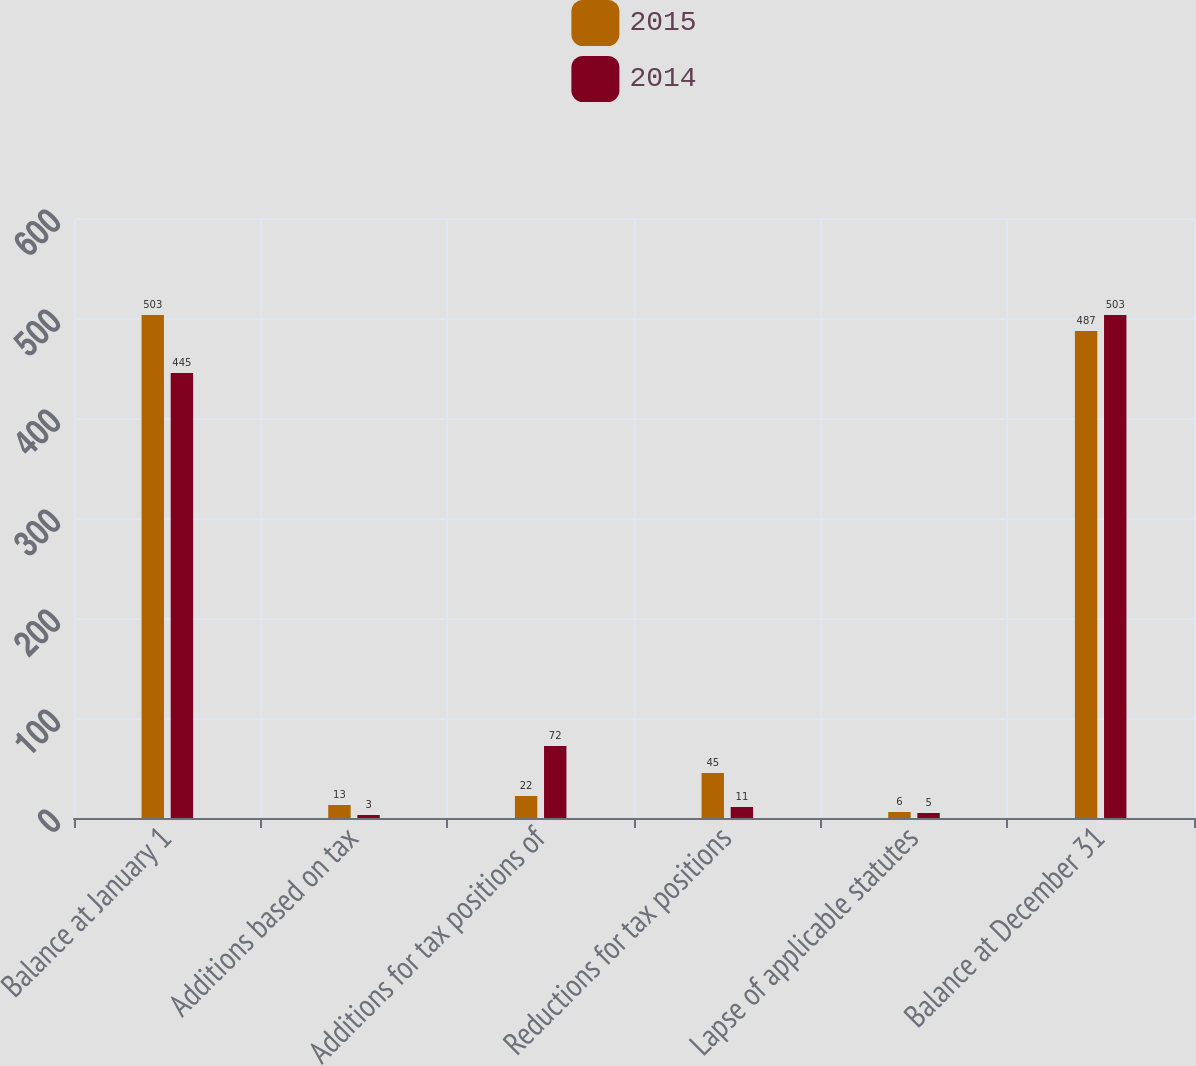<chart> <loc_0><loc_0><loc_500><loc_500><stacked_bar_chart><ecel><fcel>Balance at January 1<fcel>Additions based on tax<fcel>Additions for tax positions of<fcel>Reductions for tax positions<fcel>Lapse of applicable statutes<fcel>Balance at December 31<nl><fcel>2015<fcel>503<fcel>13<fcel>22<fcel>45<fcel>6<fcel>487<nl><fcel>2014<fcel>445<fcel>3<fcel>72<fcel>11<fcel>5<fcel>503<nl></chart> 